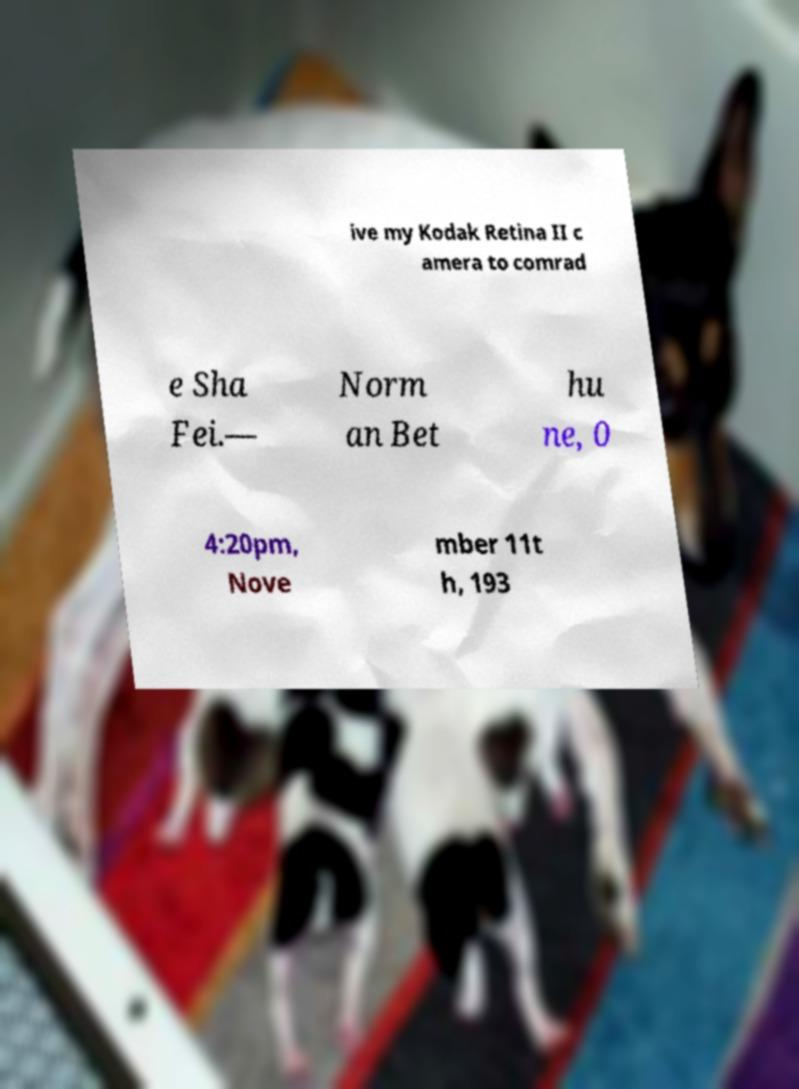I need the written content from this picture converted into text. Can you do that? ive my Kodak Retina II c amera to comrad e Sha Fei.— Norm an Bet hu ne, 0 4:20pm, Nove mber 11t h, 193 